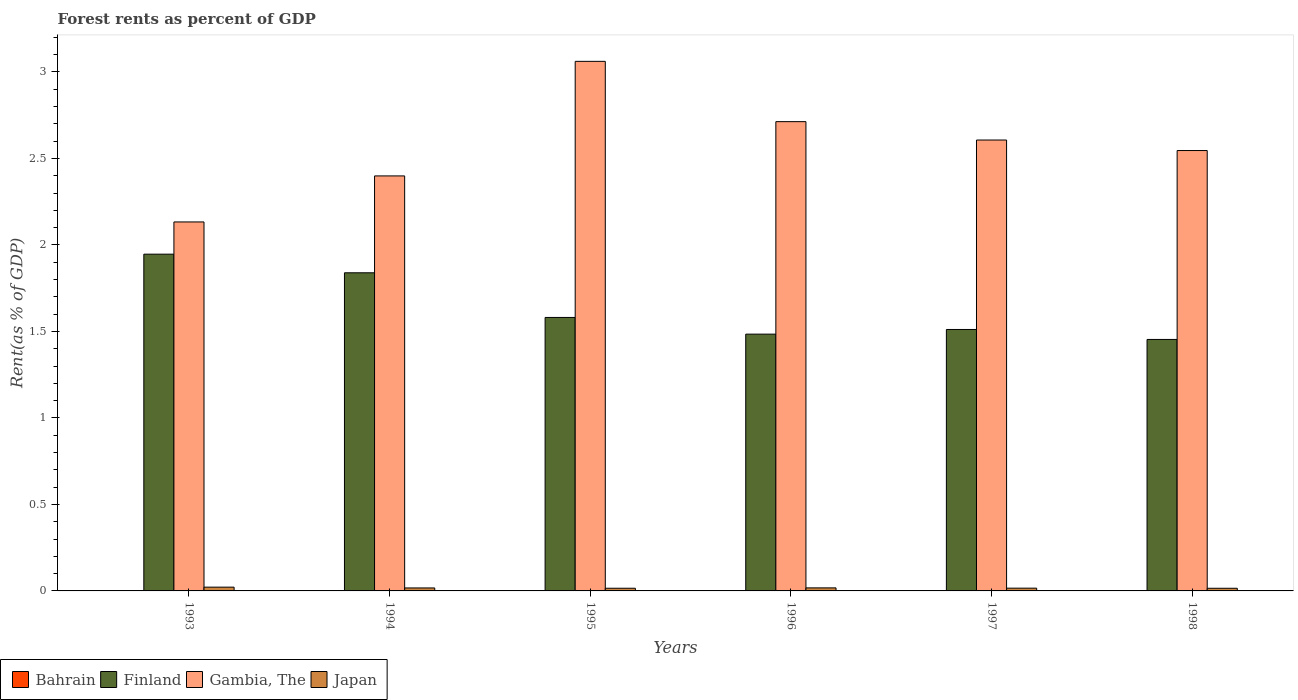How many different coloured bars are there?
Your answer should be very brief. 4. How many groups of bars are there?
Offer a terse response. 6. Are the number of bars per tick equal to the number of legend labels?
Your answer should be very brief. Yes. How many bars are there on the 1st tick from the left?
Your answer should be very brief. 4. How many bars are there on the 6th tick from the right?
Make the answer very short. 4. What is the forest rent in Finland in 1993?
Keep it short and to the point. 1.95. Across all years, what is the maximum forest rent in Finland?
Your answer should be compact. 1.95. Across all years, what is the minimum forest rent in Gambia, The?
Your answer should be very brief. 2.13. In which year was the forest rent in Finland minimum?
Offer a terse response. 1998. What is the total forest rent in Japan in the graph?
Give a very brief answer. 0.1. What is the difference between the forest rent in Japan in 1995 and that in 1996?
Your answer should be compact. -0. What is the difference between the forest rent in Gambia, The in 1993 and the forest rent in Japan in 1997?
Provide a short and direct response. 2.12. What is the average forest rent in Japan per year?
Your response must be concise. 0.02. In the year 1996, what is the difference between the forest rent in Gambia, The and forest rent in Japan?
Ensure brevity in your answer.  2.7. What is the ratio of the forest rent in Finland in 1993 to that in 1995?
Ensure brevity in your answer.  1.23. Is the difference between the forest rent in Gambia, The in 1996 and 1998 greater than the difference between the forest rent in Japan in 1996 and 1998?
Provide a short and direct response. Yes. What is the difference between the highest and the second highest forest rent in Finland?
Provide a succinct answer. 0.11. What is the difference between the highest and the lowest forest rent in Japan?
Ensure brevity in your answer.  0.01. Is it the case that in every year, the sum of the forest rent in Bahrain and forest rent in Finland is greater than the sum of forest rent in Japan and forest rent in Gambia, The?
Make the answer very short. Yes. What does the 3rd bar from the right in 1997 represents?
Your answer should be very brief. Finland. Is it the case that in every year, the sum of the forest rent in Finland and forest rent in Bahrain is greater than the forest rent in Japan?
Provide a succinct answer. Yes. How many bars are there?
Your answer should be very brief. 24. What is the difference between two consecutive major ticks on the Y-axis?
Offer a terse response. 0.5. Are the values on the major ticks of Y-axis written in scientific E-notation?
Your response must be concise. No. Does the graph contain any zero values?
Your answer should be very brief. No. Does the graph contain grids?
Your answer should be compact. No. How many legend labels are there?
Ensure brevity in your answer.  4. How are the legend labels stacked?
Give a very brief answer. Horizontal. What is the title of the graph?
Provide a short and direct response. Forest rents as percent of GDP. Does "Middle income" appear as one of the legend labels in the graph?
Ensure brevity in your answer.  No. What is the label or title of the X-axis?
Your answer should be compact. Years. What is the label or title of the Y-axis?
Keep it short and to the point. Rent(as % of GDP). What is the Rent(as % of GDP) of Bahrain in 1993?
Make the answer very short. 0. What is the Rent(as % of GDP) of Finland in 1993?
Make the answer very short. 1.95. What is the Rent(as % of GDP) of Gambia, The in 1993?
Provide a short and direct response. 2.13. What is the Rent(as % of GDP) in Japan in 1993?
Provide a succinct answer. 0.02. What is the Rent(as % of GDP) of Bahrain in 1994?
Provide a succinct answer. 0. What is the Rent(as % of GDP) of Finland in 1994?
Your response must be concise. 1.84. What is the Rent(as % of GDP) of Gambia, The in 1994?
Make the answer very short. 2.4. What is the Rent(as % of GDP) of Japan in 1994?
Your answer should be very brief. 0.02. What is the Rent(as % of GDP) in Bahrain in 1995?
Provide a short and direct response. 0. What is the Rent(as % of GDP) of Finland in 1995?
Make the answer very short. 1.58. What is the Rent(as % of GDP) of Gambia, The in 1995?
Provide a succinct answer. 3.06. What is the Rent(as % of GDP) in Japan in 1995?
Your answer should be very brief. 0.02. What is the Rent(as % of GDP) of Bahrain in 1996?
Make the answer very short. 0. What is the Rent(as % of GDP) in Finland in 1996?
Your response must be concise. 1.48. What is the Rent(as % of GDP) of Gambia, The in 1996?
Your response must be concise. 2.71. What is the Rent(as % of GDP) of Japan in 1996?
Provide a short and direct response. 0.02. What is the Rent(as % of GDP) in Bahrain in 1997?
Your response must be concise. 0. What is the Rent(as % of GDP) in Finland in 1997?
Ensure brevity in your answer.  1.51. What is the Rent(as % of GDP) of Gambia, The in 1997?
Give a very brief answer. 2.61. What is the Rent(as % of GDP) of Japan in 1997?
Offer a terse response. 0.02. What is the Rent(as % of GDP) in Bahrain in 1998?
Ensure brevity in your answer.  0. What is the Rent(as % of GDP) of Finland in 1998?
Keep it short and to the point. 1.45. What is the Rent(as % of GDP) in Gambia, The in 1998?
Your response must be concise. 2.55. What is the Rent(as % of GDP) in Japan in 1998?
Offer a terse response. 0.02. Across all years, what is the maximum Rent(as % of GDP) of Bahrain?
Provide a short and direct response. 0. Across all years, what is the maximum Rent(as % of GDP) in Finland?
Provide a short and direct response. 1.95. Across all years, what is the maximum Rent(as % of GDP) in Gambia, The?
Ensure brevity in your answer.  3.06. Across all years, what is the maximum Rent(as % of GDP) in Japan?
Offer a terse response. 0.02. Across all years, what is the minimum Rent(as % of GDP) of Bahrain?
Offer a terse response. 0. Across all years, what is the minimum Rent(as % of GDP) of Finland?
Keep it short and to the point. 1.45. Across all years, what is the minimum Rent(as % of GDP) in Gambia, The?
Ensure brevity in your answer.  2.13. Across all years, what is the minimum Rent(as % of GDP) of Japan?
Your answer should be compact. 0.02. What is the total Rent(as % of GDP) of Bahrain in the graph?
Provide a short and direct response. 0.01. What is the total Rent(as % of GDP) of Finland in the graph?
Your response must be concise. 9.82. What is the total Rent(as % of GDP) of Gambia, The in the graph?
Give a very brief answer. 15.46. What is the total Rent(as % of GDP) in Japan in the graph?
Provide a succinct answer. 0.1. What is the difference between the Rent(as % of GDP) in Finland in 1993 and that in 1994?
Ensure brevity in your answer.  0.11. What is the difference between the Rent(as % of GDP) of Gambia, The in 1993 and that in 1994?
Ensure brevity in your answer.  -0.27. What is the difference between the Rent(as % of GDP) in Japan in 1993 and that in 1994?
Provide a succinct answer. 0. What is the difference between the Rent(as % of GDP) of Finland in 1993 and that in 1995?
Provide a succinct answer. 0.37. What is the difference between the Rent(as % of GDP) in Gambia, The in 1993 and that in 1995?
Provide a short and direct response. -0.93. What is the difference between the Rent(as % of GDP) in Japan in 1993 and that in 1995?
Make the answer very short. 0.01. What is the difference between the Rent(as % of GDP) in Bahrain in 1993 and that in 1996?
Your answer should be compact. 0. What is the difference between the Rent(as % of GDP) in Finland in 1993 and that in 1996?
Give a very brief answer. 0.46. What is the difference between the Rent(as % of GDP) of Gambia, The in 1993 and that in 1996?
Make the answer very short. -0.58. What is the difference between the Rent(as % of GDP) of Japan in 1993 and that in 1996?
Your answer should be very brief. 0. What is the difference between the Rent(as % of GDP) of Bahrain in 1993 and that in 1997?
Ensure brevity in your answer.  -0. What is the difference between the Rent(as % of GDP) of Finland in 1993 and that in 1997?
Offer a very short reply. 0.44. What is the difference between the Rent(as % of GDP) of Gambia, The in 1993 and that in 1997?
Make the answer very short. -0.47. What is the difference between the Rent(as % of GDP) in Japan in 1993 and that in 1997?
Make the answer very short. 0.01. What is the difference between the Rent(as % of GDP) of Bahrain in 1993 and that in 1998?
Ensure brevity in your answer.  -0. What is the difference between the Rent(as % of GDP) in Finland in 1993 and that in 1998?
Give a very brief answer. 0.49. What is the difference between the Rent(as % of GDP) of Gambia, The in 1993 and that in 1998?
Give a very brief answer. -0.41. What is the difference between the Rent(as % of GDP) in Japan in 1993 and that in 1998?
Ensure brevity in your answer.  0.01. What is the difference between the Rent(as % of GDP) in Bahrain in 1994 and that in 1995?
Give a very brief answer. -0. What is the difference between the Rent(as % of GDP) in Finland in 1994 and that in 1995?
Give a very brief answer. 0.26. What is the difference between the Rent(as % of GDP) of Gambia, The in 1994 and that in 1995?
Your response must be concise. -0.66. What is the difference between the Rent(as % of GDP) in Japan in 1994 and that in 1995?
Give a very brief answer. 0. What is the difference between the Rent(as % of GDP) of Bahrain in 1994 and that in 1996?
Offer a very short reply. -0. What is the difference between the Rent(as % of GDP) of Finland in 1994 and that in 1996?
Your response must be concise. 0.35. What is the difference between the Rent(as % of GDP) in Gambia, The in 1994 and that in 1996?
Make the answer very short. -0.31. What is the difference between the Rent(as % of GDP) of Japan in 1994 and that in 1996?
Make the answer very short. -0. What is the difference between the Rent(as % of GDP) in Bahrain in 1994 and that in 1997?
Ensure brevity in your answer.  -0. What is the difference between the Rent(as % of GDP) in Finland in 1994 and that in 1997?
Your response must be concise. 0.33. What is the difference between the Rent(as % of GDP) in Gambia, The in 1994 and that in 1997?
Ensure brevity in your answer.  -0.21. What is the difference between the Rent(as % of GDP) in Japan in 1994 and that in 1997?
Offer a very short reply. 0. What is the difference between the Rent(as % of GDP) of Bahrain in 1994 and that in 1998?
Ensure brevity in your answer.  -0. What is the difference between the Rent(as % of GDP) of Finland in 1994 and that in 1998?
Offer a very short reply. 0.39. What is the difference between the Rent(as % of GDP) in Gambia, The in 1994 and that in 1998?
Your response must be concise. -0.15. What is the difference between the Rent(as % of GDP) of Japan in 1994 and that in 1998?
Make the answer very short. 0. What is the difference between the Rent(as % of GDP) in Bahrain in 1995 and that in 1996?
Your response must be concise. -0. What is the difference between the Rent(as % of GDP) in Finland in 1995 and that in 1996?
Your response must be concise. 0.1. What is the difference between the Rent(as % of GDP) of Gambia, The in 1995 and that in 1996?
Offer a terse response. 0.35. What is the difference between the Rent(as % of GDP) of Japan in 1995 and that in 1996?
Offer a terse response. -0. What is the difference between the Rent(as % of GDP) of Bahrain in 1995 and that in 1997?
Your answer should be compact. -0. What is the difference between the Rent(as % of GDP) of Finland in 1995 and that in 1997?
Provide a succinct answer. 0.07. What is the difference between the Rent(as % of GDP) in Gambia, The in 1995 and that in 1997?
Offer a terse response. 0.45. What is the difference between the Rent(as % of GDP) of Japan in 1995 and that in 1997?
Offer a very short reply. -0. What is the difference between the Rent(as % of GDP) of Bahrain in 1995 and that in 1998?
Provide a short and direct response. -0. What is the difference between the Rent(as % of GDP) in Finland in 1995 and that in 1998?
Offer a very short reply. 0.13. What is the difference between the Rent(as % of GDP) of Gambia, The in 1995 and that in 1998?
Make the answer very short. 0.52. What is the difference between the Rent(as % of GDP) in Bahrain in 1996 and that in 1997?
Offer a terse response. -0. What is the difference between the Rent(as % of GDP) in Finland in 1996 and that in 1997?
Keep it short and to the point. -0.03. What is the difference between the Rent(as % of GDP) of Gambia, The in 1996 and that in 1997?
Give a very brief answer. 0.11. What is the difference between the Rent(as % of GDP) of Japan in 1996 and that in 1997?
Offer a terse response. 0. What is the difference between the Rent(as % of GDP) of Bahrain in 1996 and that in 1998?
Offer a terse response. -0. What is the difference between the Rent(as % of GDP) of Finland in 1996 and that in 1998?
Your response must be concise. 0.03. What is the difference between the Rent(as % of GDP) in Gambia, The in 1996 and that in 1998?
Ensure brevity in your answer.  0.17. What is the difference between the Rent(as % of GDP) of Japan in 1996 and that in 1998?
Provide a short and direct response. 0. What is the difference between the Rent(as % of GDP) of Bahrain in 1997 and that in 1998?
Your answer should be very brief. -0. What is the difference between the Rent(as % of GDP) in Finland in 1997 and that in 1998?
Ensure brevity in your answer.  0.06. What is the difference between the Rent(as % of GDP) in Gambia, The in 1997 and that in 1998?
Offer a terse response. 0.06. What is the difference between the Rent(as % of GDP) of Japan in 1997 and that in 1998?
Offer a very short reply. 0. What is the difference between the Rent(as % of GDP) of Bahrain in 1993 and the Rent(as % of GDP) of Finland in 1994?
Provide a succinct answer. -1.84. What is the difference between the Rent(as % of GDP) in Bahrain in 1993 and the Rent(as % of GDP) in Gambia, The in 1994?
Provide a succinct answer. -2.4. What is the difference between the Rent(as % of GDP) of Bahrain in 1993 and the Rent(as % of GDP) of Japan in 1994?
Offer a very short reply. -0.02. What is the difference between the Rent(as % of GDP) in Finland in 1993 and the Rent(as % of GDP) in Gambia, The in 1994?
Ensure brevity in your answer.  -0.45. What is the difference between the Rent(as % of GDP) in Finland in 1993 and the Rent(as % of GDP) in Japan in 1994?
Keep it short and to the point. 1.93. What is the difference between the Rent(as % of GDP) in Gambia, The in 1993 and the Rent(as % of GDP) in Japan in 1994?
Your answer should be compact. 2.12. What is the difference between the Rent(as % of GDP) of Bahrain in 1993 and the Rent(as % of GDP) of Finland in 1995?
Offer a terse response. -1.58. What is the difference between the Rent(as % of GDP) of Bahrain in 1993 and the Rent(as % of GDP) of Gambia, The in 1995?
Keep it short and to the point. -3.06. What is the difference between the Rent(as % of GDP) in Bahrain in 1993 and the Rent(as % of GDP) in Japan in 1995?
Offer a terse response. -0.01. What is the difference between the Rent(as % of GDP) in Finland in 1993 and the Rent(as % of GDP) in Gambia, The in 1995?
Provide a short and direct response. -1.11. What is the difference between the Rent(as % of GDP) of Finland in 1993 and the Rent(as % of GDP) of Japan in 1995?
Offer a very short reply. 1.93. What is the difference between the Rent(as % of GDP) in Gambia, The in 1993 and the Rent(as % of GDP) in Japan in 1995?
Your answer should be compact. 2.12. What is the difference between the Rent(as % of GDP) in Bahrain in 1993 and the Rent(as % of GDP) in Finland in 1996?
Provide a short and direct response. -1.48. What is the difference between the Rent(as % of GDP) in Bahrain in 1993 and the Rent(as % of GDP) in Gambia, The in 1996?
Offer a very short reply. -2.71. What is the difference between the Rent(as % of GDP) of Bahrain in 1993 and the Rent(as % of GDP) of Japan in 1996?
Your response must be concise. -0.02. What is the difference between the Rent(as % of GDP) of Finland in 1993 and the Rent(as % of GDP) of Gambia, The in 1996?
Provide a succinct answer. -0.77. What is the difference between the Rent(as % of GDP) in Finland in 1993 and the Rent(as % of GDP) in Japan in 1996?
Make the answer very short. 1.93. What is the difference between the Rent(as % of GDP) in Gambia, The in 1993 and the Rent(as % of GDP) in Japan in 1996?
Your answer should be compact. 2.12. What is the difference between the Rent(as % of GDP) of Bahrain in 1993 and the Rent(as % of GDP) of Finland in 1997?
Ensure brevity in your answer.  -1.51. What is the difference between the Rent(as % of GDP) in Bahrain in 1993 and the Rent(as % of GDP) in Gambia, The in 1997?
Give a very brief answer. -2.6. What is the difference between the Rent(as % of GDP) of Bahrain in 1993 and the Rent(as % of GDP) of Japan in 1997?
Your response must be concise. -0.01. What is the difference between the Rent(as % of GDP) of Finland in 1993 and the Rent(as % of GDP) of Gambia, The in 1997?
Keep it short and to the point. -0.66. What is the difference between the Rent(as % of GDP) in Finland in 1993 and the Rent(as % of GDP) in Japan in 1997?
Make the answer very short. 1.93. What is the difference between the Rent(as % of GDP) in Gambia, The in 1993 and the Rent(as % of GDP) in Japan in 1997?
Make the answer very short. 2.12. What is the difference between the Rent(as % of GDP) in Bahrain in 1993 and the Rent(as % of GDP) in Finland in 1998?
Provide a short and direct response. -1.45. What is the difference between the Rent(as % of GDP) of Bahrain in 1993 and the Rent(as % of GDP) of Gambia, The in 1998?
Offer a very short reply. -2.54. What is the difference between the Rent(as % of GDP) of Bahrain in 1993 and the Rent(as % of GDP) of Japan in 1998?
Your answer should be compact. -0.01. What is the difference between the Rent(as % of GDP) of Finland in 1993 and the Rent(as % of GDP) of Gambia, The in 1998?
Make the answer very short. -0.6. What is the difference between the Rent(as % of GDP) of Finland in 1993 and the Rent(as % of GDP) of Japan in 1998?
Ensure brevity in your answer.  1.93. What is the difference between the Rent(as % of GDP) of Gambia, The in 1993 and the Rent(as % of GDP) of Japan in 1998?
Offer a terse response. 2.12. What is the difference between the Rent(as % of GDP) in Bahrain in 1994 and the Rent(as % of GDP) in Finland in 1995?
Offer a terse response. -1.58. What is the difference between the Rent(as % of GDP) in Bahrain in 1994 and the Rent(as % of GDP) in Gambia, The in 1995?
Make the answer very short. -3.06. What is the difference between the Rent(as % of GDP) of Bahrain in 1994 and the Rent(as % of GDP) of Japan in 1995?
Your answer should be compact. -0.01. What is the difference between the Rent(as % of GDP) in Finland in 1994 and the Rent(as % of GDP) in Gambia, The in 1995?
Give a very brief answer. -1.22. What is the difference between the Rent(as % of GDP) in Finland in 1994 and the Rent(as % of GDP) in Japan in 1995?
Give a very brief answer. 1.82. What is the difference between the Rent(as % of GDP) of Gambia, The in 1994 and the Rent(as % of GDP) of Japan in 1995?
Your answer should be very brief. 2.38. What is the difference between the Rent(as % of GDP) of Bahrain in 1994 and the Rent(as % of GDP) of Finland in 1996?
Give a very brief answer. -1.48. What is the difference between the Rent(as % of GDP) in Bahrain in 1994 and the Rent(as % of GDP) in Gambia, The in 1996?
Offer a terse response. -2.71. What is the difference between the Rent(as % of GDP) in Bahrain in 1994 and the Rent(as % of GDP) in Japan in 1996?
Offer a very short reply. -0.02. What is the difference between the Rent(as % of GDP) in Finland in 1994 and the Rent(as % of GDP) in Gambia, The in 1996?
Your response must be concise. -0.87. What is the difference between the Rent(as % of GDP) in Finland in 1994 and the Rent(as % of GDP) in Japan in 1996?
Offer a terse response. 1.82. What is the difference between the Rent(as % of GDP) in Gambia, The in 1994 and the Rent(as % of GDP) in Japan in 1996?
Ensure brevity in your answer.  2.38. What is the difference between the Rent(as % of GDP) in Bahrain in 1994 and the Rent(as % of GDP) in Finland in 1997?
Your answer should be compact. -1.51. What is the difference between the Rent(as % of GDP) in Bahrain in 1994 and the Rent(as % of GDP) in Gambia, The in 1997?
Your response must be concise. -2.61. What is the difference between the Rent(as % of GDP) in Bahrain in 1994 and the Rent(as % of GDP) in Japan in 1997?
Make the answer very short. -0.01. What is the difference between the Rent(as % of GDP) of Finland in 1994 and the Rent(as % of GDP) of Gambia, The in 1997?
Your answer should be compact. -0.77. What is the difference between the Rent(as % of GDP) in Finland in 1994 and the Rent(as % of GDP) in Japan in 1997?
Provide a succinct answer. 1.82. What is the difference between the Rent(as % of GDP) of Gambia, The in 1994 and the Rent(as % of GDP) of Japan in 1997?
Your answer should be very brief. 2.38. What is the difference between the Rent(as % of GDP) in Bahrain in 1994 and the Rent(as % of GDP) in Finland in 1998?
Keep it short and to the point. -1.45. What is the difference between the Rent(as % of GDP) in Bahrain in 1994 and the Rent(as % of GDP) in Gambia, The in 1998?
Your answer should be very brief. -2.54. What is the difference between the Rent(as % of GDP) of Bahrain in 1994 and the Rent(as % of GDP) of Japan in 1998?
Give a very brief answer. -0.01. What is the difference between the Rent(as % of GDP) in Finland in 1994 and the Rent(as % of GDP) in Gambia, The in 1998?
Provide a short and direct response. -0.71. What is the difference between the Rent(as % of GDP) in Finland in 1994 and the Rent(as % of GDP) in Japan in 1998?
Your answer should be compact. 1.82. What is the difference between the Rent(as % of GDP) of Gambia, The in 1994 and the Rent(as % of GDP) of Japan in 1998?
Your answer should be compact. 2.38. What is the difference between the Rent(as % of GDP) in Bahrain in 1995 and the Rent(as % of GDP) in Finland in 1996?
Provide a succinct answer. -1.48. What is the difference between the Rent(as % of GDP) in Bahrain in 1995 and the Rent(as % of GDP) in Gambia, The in 1996?
Provide a succinct answer. -2.71. What is the difference between the Rent(as % of GDP) of Bahrain in 1995 and the Rent(as % of GDP) of Japan in 1996?
Ensure brevity in your answer.  -0.02. What is the difference between the Rent(as % of GDP) of Finland in 1995 and the Rent(as % of GDP) of Gambia, The in 1996?
Give a very brief answer. -1.13. What is the difference between the Rent(as % of GDP) in Finland in 1995 and the Rent(as % of GDP) in Japan in 1996?
Keep it short and to the point. 1.56. What is the difference between the Rent(as % of GDP) of Gambia, The in 1995 and the Rent(as % of GDP) of Japan in 1996?
Offer a very short reply. 3.04. What is the difference between the Rent(as % of GDP) in Bahrain in 1995 and the Rent(as % of GDP) in Finland in 1997?
Provide a succinct answer. -1.51. What is the difference between the Rent(as % of GDP) of Bahrain in 1995 and the Rent(as % of GDP) of Gambia, The in 1997?
Give a very brief answer. -2.6. What is the difference between the Rent(as % of GDP) in Bahrain in 1995 and the Rent(as % of GDP) in Japan in 1997?
Offer a very short reply. -0.01. What is the difference between the Rent(as % of GDP) in Finland in 1995 and the Rent(as % of GDP) in Gambia, The in 1997?
Your response must be concise. -1.03. What is the difference between the Rent(as % of GDP) in Finland in 1995 and the Rent(as % of GDP) in Japan in 1997?
Provide a short and direct response. 1.56. What is the difference between the Rent(as % of GDP) in Gambia, The in 1995 and the Rent(as % of GDP) in Japan in 1997?
Keep it short and to the point. 3.05. What is the difference between the Rent(as % of GDP) of Bahrain in 1995 and the Rent(as % of GDP) of Finland in 1998?
Offer a terse response. -1.45. What is the difference between the Rent(as % of GDP) of Bahrain in 1995 and the Rent(as % of GDP) of Gambia, The in 1998?
Ensure brevity in your answer.  -2.54. What is the difference between the Rent(as % of GDP) in Bahrain in 1995 and the Rent(as % of GDP) in Japan in 1998?
Keep it short and to the point. -0.01. What is the difference between the Rent(as % of GDP) of Finland in 1995 and the Rent(as % of GDP) of Gambia, The in 1998?
Ensure brevity in your answer.  -0.96. What is the difference between the Rent(as % of GDP) of Finland in 1995 and the Rent(as % of GDP) of Japan in 1998?
Your answer should be very brief. 1.57. What is the difference between the Rent(as % of GDP) of Gambia, The in 1995 and the Rent(as % of GDP) of Japan in 1998?
Your response must be concise. 3.05. What is the difference between the Rent(as % of GDP) of Bahrain in 1996 and the Rent(as % of GDP) of Finland in 1997?
Keep it short and to the point. -1.51. What is the difference between the Rent(as % of GDP) of Bahrain in 1996 and the Rent(as % of GDP) of Gambia, The in 1997?
Provide a succinct answer. -2.6. What is the difference between the Rent(as % of GDP) in Bahrain in 1996 and the Rent(as % of GDP) in Japan in 1997?
Make the answer very short. -0.01. What is the difference between the Rent(as % of GDP) in Finland in 1996 and the Rent(as % of GDP) in Gambia, The in 1997?
Provide a succinct answer. -1.12. What is the difference between the Rent(as % of GDP) of Finland in 1996 and the Rent(as % of GDP) of Japan in 1997?
Offer a very short reply. 1.47. What is the difference between the Rent(as % of GDP) in Gambia, The in 1996 and the Rent(as % of GDP) in Japan in 1997?
Give a very brief answer. 2.7. What is the difference between the Rent(as % of GDP) of Bahrain in 1996 and the Rent(as % of GDP) of Finland in 1998?
Make the answer very short. -1.45. What is the difference between the Rent(as % of GDP) of Bahrain in 1996 and the Rent(as % of GDP) of Gambia, The in 1998?
Provide a succinct answer. -2.54. What is the difference between the Rent(as % of GDP) of Bahrain in 1996 and the Rent(as % of GDP) of Japan in 1998?
Keep it short and to the point. -0.01. What is the difference between the Rent(as % of GDP) of Finland in 1996 and the Rent(as % of GDP) of Gambia, The in 1998?
Provide a succinct answer. -1.06. What is the difference between the Rent(as % of GDP) of Finland in 1996 and the Rent(as % of GDP) of Japan in 1998?
Your answer should be compact. 1.47. What is the difference between the Rent(as % of GDP) in Gambia, The in 1996 and the Rent(as % of GDP) in Japan in 1998?
Offer a terse response. 2.7. What is the difference between the Rent(as % of GDP) in Bahrain in 1997 and the Rent(as % of GDP) in Finland in 1998?
Your response must be concise. -1.45. What is the difference between the Rent(as % of GDP) of Bahrain in 1997 and the Rent(as % of GDP) of Gambia, The in 1998?
Give a very brief answer. -2.54. What is the difference between the Rent(as % of GDP) in Bahrain in 1997 and the Rent(as % of GDP) in Japan in 1998?
Offer a very short reply. -0.01. What is the difference between the Rent(as % of GDP) in Finland in 1997 and the Rent(as % of GDP) in Gambia, The in 1998?
Keep it short and to the point. -1.03. What is the difference between the Rent(as % of GDP) of Finland in 1997 and the Rent(as % of GDP) of Japan in 1998?
Provide a succinct answer. 1.5. What is the difference between the Rent(as % of GDP) of Gambia, The in 1997 and the Rent(as % of GDP) of Japan in 1998?
Make the answer very short. 2.59. What is the average Rent(as % of GDP) of Bahrain per year?
Provide a succinct answer. 0. What is the average Rent(as % of GDP) of Finland per year?
Your answer should be very brief. 1.64. What is the average Rent(as % of GDP) of Gambia, The per year?
Make the answer very short. 2.58. What is the average Rent(as % of GDP) of Japan per year?
Provide a short and direct response. 0.02. In the year 1993, what is the difference between the Rent(as % of GDP) in Bahrain and Rent(as % of GDP) in Finland?
Make the answer very short. -1.95. In the year 1993, what is the difference between the Rent(as % of GDP) in Bahrain and Rent(as % of GDP) in Gambia, The?
Provide a succinct answer. -2.13. In the year 1993, what is the difference between the Rent(as % of GDP) of Bahrain and Rent(as % of GDP) of Japan?
Make the answer very short. -0.02. In the year 1993, what is the difference between the Rent(as % of GDP) of Finland and Rent(as % of GDP) of Gambia, The?
Offer a very short reply. -0.19. In the year 1993, what is the difference between the Rent(as % of GDP) in Finland and Rent(as % of GDP) in Japan?
Give a very brief answer. 1.92. In the year 1993, what is the difference between the Rent(as % of GDP) in Gambia, The and Rent(as % of GDP) in Japan?
Offer a terse response. 2.11. In the year 1994, what is the difference between the Rent(as % of GDP) of Bahrain and Rent(as % of GDP) of Finland?
Your answer should be very brief. -1.84. In the year 1994, what is the difference between the Rent(as % of GDP) in Bahrain and Rent(as % of GDP) in Gambia, The?
Your answer should be very brief. -2.4. In the year 1994, what is the difference between the Rent(as % of GDP) in Bahrain and Rent(as % of GDP) in Japan?
Provide a short and direct response. -0.02. In the year 1994, what is the difference between the Rent(as % of GDP) in Finland and Rent(as % of GDP) in Gambia, The?
Give a very brief answer. -0.56. In the year 1994, what is the difference between the Rent(as % of GDP) of Finland and Rent(as % of GDP) of Japan?
Provide a succinct answer. 1.82. In the year 1994, what is the difference between the Rent(as % of GDP) in Gambia, The and Rent(as % of GDP) in Japan?
Ensure brevity in your answer.  2.38. In the year 1995, what is the difference between the Rent(as % of GDP) in Bahrain and Rent(as % of GDP) in Finland?
Keep it short and to the point. -1.58. In the year 1995, what is the difference between the Rent(as % of GDP) of Bahrain and Rent(as % of GDP) of Gambia, The?
Keep it short and to the point. -3.06. In the year 1995, what is the difference between the Rent(as % of GDP) in Bahrain and Rent(as % of GDP) in Japan?
Make the answer very short. -0.01. In the year 1995, what is the difference between the Rent(as % of GDP) of Finland and Rent(as % of GDP) of Gambia, The?
Give a very brief answer. -1.48. In the year 1995, what is the difference between the Rent(as % of GDP) in Finland and Rent(as % of GDP) in Japan?
Provide a short and direct response. 1.57. In the year 1995, what is the difference between the Rent(as % of GDP) in Gambia, The and Rent(as % of GDP) in Japan?
Ensure brevity in your answer.  3.05. In the year 1996, what is the difference between the Rent(as % of GDP) in Bahrain and Rent(as % of GDP) in Finland?
Offer a very short reply. -1.48. In the year 1996, what is the difference between the Rent(as % of GDP) in Bahrain and Rent(as % of GDP) in Gambia, The?
Your answer should be very brief. -2.71. In the year 1996, what is the difference between the Rent(as % of GDP) of Bahrain and Rent(as % of GDP) of Japan?
Offer a very short reply. -0.02. In the year 1996, what is the difference between the Rent(as % of GDP) of Finland and Rent(as % of GDP) of Gambia, The?
Provide a succinct answer. -1.23. In the year 1996, what is the difference between the Rent(as % of GDP) in Finland and Rent(as % of GDP) in Japan?
Your answer should be very brief. 1.47. In the year 1996, what is the difference between the Rent(as % of GDP) in Gambia, The and Rent(as % of GDP) in Japan?
Make the answer very short. 2.69. In the year 1997, what is the difference between the Rent(as % of GDP) in Bahrain and Rent(as % of GDP) in Finland?
Your answer should be compact. -1.51. In the year 1997, what is the difference between the Rent(as % of GDP) in Bahrain and Rent(as % of GDP) in Gambia, The?
Keep it short and to the point. -2.6. In the year 1997, what is the difference between the Rent(as % of GDP) of Bahrain and Rent(as % of GDP) of Japan?
Ensure brevity in your answer.  -0.01. In the year 1997, what is the difference between the Rent(as % of GDP) of Finland and Rent(as % of GDP) of Gambia, The?
Keep it short and to the point. -1.1. In the year 1997, what is the difference between the Rent(as % of GDP) of Finland and Rent(as % of GDP) of Japan?
Give a very brief answer. 1.5. In the year 1997, what is the difference between the Rent(as % of GDP) in Gambia, The and Rent(as % of GDP) in Japan?
Your response must be concise. 2.59. In the year 1998, what is the difference between the Rent(as % of GDP) of Bahrain and Rent(as % of GDP) of Finland?
Your answer should be very brief. -1.45. In the year 1998, what is the difference between the Rent(as % of GDP) of Bahrain and Rent(as % of GDP) of Gambia, The?
Offer a terse response. -2.54. In the year 1998, what is the difference between the Rent(as % of GDP) in Bahrain and Rent(as % of GDP) in Japan?
Make the answer very short. -0.01. In the year 1998, what is the difference between the Rent(as % of GDP) of Finland and Rent(as % of GDP) of Gambia, The?
Give a very brief answer. -1.09. In the year 1998, what is the difference between the Rent(as % of GDP) in Finland and Rent(as % of GDP) in Japan?
Your answer should be compact. 1.44. In the year 1998, what is the difference between the Rent(as % of GDP) in Gambia, The and Rent(as % of GDP) in Japan?
Give a very brief answer. 2.53. What is the ratio of the Rent(as % of GDP) of Bahrain in 1993 to that in 1994?
Offer a very short reply. 1.38. What is the ratio of the Rent(as % of GDP) in Finland in 1993 to that in 1994?
Ensure brevity in your answer.  1.06. What is the ratio of the Rent(as % of GDP) of Gambia, The in 1993 to that in 1994?
Ensure brevity in your answer.  0.89. What is the ratio of the Rent(as % of GDP) in Japan in 1993 to that in 1994?
Your answer should be compact. 1.27. What is the ratio of the Rent(as % of GDP) of Bahrain in 1993 to that in 1995?
Offer a very short reply. 1.15. What is the ratio of the Rent(as % of GDP) in Finland in 1993 to that in 1995?
Offer a very short reply. 1.23. What is the ratio of the Rent(as % of GDP) of Gambia, The in 1993 to that in 1995?
Provide a succinct answer. 0.7. What is the ratio of the Rent(as % of GDP) in Japan in 1993 to that in 1995?
Provide a succinct answer. 1.41. What is the ratio of the Rent(as % of GDP) in Bahrain in 1993 to that in 1996?
Provide a succinct answer. 1.02. What is the ratio of the Rent(as % of GDP) in Finland in 1993 to that in 1996?
Offer a very short reply. 1.31. What is the ratio of the Rent(as % of GDP) in Gambia, The in 1993 to that in 1996?
Offer a very short reply. 0.79. What is the ratio of the Rent(as % of GDP) in Japan in 1993 to that in 1996?
Provide a succinct answer. 1.24. What is the ratio of the Rent(as % of GDP) of Bahrain in 1993 to that in 1997?
Keep it short and to the point. 0.91. What is the ratio of the Rent(as % of GDP) of Finland in 1993 to that in 1997?
Give a very brief answer. 1.29. What is the ratio of the Rent(as % of GDP) in Gambia, The in 1993 to that in 1997?
Keep it short and to the point. 0.82. What is the ratio of the Rent(as % of GDP) in Japan in 1993 to that in 1997?
Keep it short and to the point. 1.37. What is the ratio of the Rent(as % of GDP) in Bahrain in 1993 to that in 1998?
Give a very brief answer. 0.85. What is the ratio of the Rent(as % of GDP) in Finland in 1993 to that in 1998?
Your answer should be very brief. 1.34. What is the ratio of the Rent(as % of GDP) of Gambia, The in 1993 to that in 1998?
Your response must be concise. 0.84. What is the ratio of the Rent(as % of GDP) of Japan in 1993 to that in 1998?
Provide a succinct answer. 1.43. What is the ratio of the Rent(as % of GDP) in Bahrain in 1994 to that in 1995?
Your answer should be compact. 0.84. What is the ratio of the Rent(as % of GDP) of Finland in 1994 to that in 1995?
Offer a terse response. 1.16. What is the ratio of the Rent(as % of GDP) of Gambia, The in 1994 to that in 1995?
Provide a short and direct response. 0.78. What is the ratio of the Rent(as % of GDP) in Japan in 1994 to that in 1995?
Provide a short and direct response. 1.11. What is the ratio of the Rent(as % of GDP) of Bahrain in 1994 to that in 1996?
Make the answer very short. 0.74. What is the ratio of the Rent(as % of GDP) of Finland in 1994 to that in 1996?
Offer a terse response. 1.24. What is the ratio of the Rent(as % of GDP) in Gambia, The in 1994 to that in 1996?
Give a very brief answer. 0.88. What is the ratio of the Rent(as % of GDP) in Japan in 1994 to that in 1996?
Ensure brevity in your answer.  0.98. What is the ratio of the Rent(as % of GDP) in Bahrain in 1994 to that in 1997?
Offer a terse response. 0.66. What is the ratio of the Rent(as % of GDP) of Finland in 1994 to that in 1997?
Offer a terse response. 1.22. What is the ratio of the Rent(as % of GDP) of Gambia, The in 1994 to that in 1997?
Offer a very short reply. 0.92. What is the ratio of the Rent(as % of GDP) of Japan in 1994 to that in 1997?
Give a very brief answer. 1.08. What is the ratio of the Rent(as % of GDP) in Bahrain in 1994 to that in 1998?
Offer a terse response. 0.62. What is the ratio of the Rent(as % of GDP) in Finland in 1994 to that in 1998?
Give a very brief answer. 1.27. What is the ratio of the Rent(as % of GDP) of Gambia, The in 1994 to that in 1998?
Your response must be concise. 0.94. What is the ratio of the Rent(as % of GDP) of Japan in 1994 to that in 1998?
Give a very brief answer. 1.12. What is the ratio of the Rent(as % of GDP) in Bahrain in 1995 to that in 1996?
Make the answer very short. 0.89. What is the ratio of the Rent(as % of GDP) in Finland in 1995 to that in 1996?
Your answer should be very brief. 1.06. What is the ratio of the Rent(as % of GDP) of Gambia, The in 1995 to that in 1996?
Provide a succinct answer. 1.13. What is the ratio of the Rent(as % of GDP) in Japan in 1995 to that in 1996?
Make the answer very short. 0.88. What is the ratio of the Rent(as % of GDP) of Bahrain in 1995 to that in 1997?
Offer a terse response. 0.79. What is the ratio of the Rent(as % of GDP) of Finland in 1995 to that in 1997?
Provide a succinct answer. 1.05. What is the ratio of the Rent(as % of GDP) in Gambia, The in 1995 to that in 1997?
Your answer should be very brief. 1.17. What is the ratio of the Rent(as % of GDP) of Japan in 1995 to that in 1997?
Keep it short and to the point. 0.97. What is the ratio of the Rent(as % of GDP) in Bahrain in 1995 to that in 1998?
Provide a short and direct response. 0.74. What is the ratio of the Rent(as % of GDP) of Finland in 1995 to that in 1998?
Give a very brief answer. 1.09. What is the ratio of the Rent(as % of GDP) of Gambia, The in 1995 to that in 1998?
Your answer should be compact. 1.2. What is the ratio of the Rent(as % of GDP) in Japan in 1995 to that in 1998?
Provide a succinct answer. 1.01. What is the ratio of the Rent(as % of GDP) in Bahrain in 1996 to that in 1997?
Make the answer very short. 0.89. What is the ratio of the Rent(as % of GDP) in Finland in 1996 to that in 1997?
Your response must be concise. 0.98. What is the ratio of the Rent(as % of GDP) in Gambia, The in 1996 to that in 1997?
Offer a very short reply. 1.04. What is the ratio of the Rent(as % of GDP) of Japan in 1996 to that in 1997?
Keep it short and to the point. 1.1. What is the ratio of the Rent(as % of GDP) in Bahrain in 1996 to that in 1998?
Make the answer very short. 0.84. What is the ratio of the Rent(as % of GDP) of Finland in 1996 to that in 1998?
Provide a short and direct response. 1.02. What is the ratio of the Rent(as % of GDP) in Gambia, The in 1996 to that in 1998?
Offer a very short reply. 1.07. What is the ratio of the Rent(as % of GDP) in Japan in 1996 to that in 1998?
Provide a succinct answer. 1.15. What is the ratio of the Rent(as % of GDP) in Bahrain in 1997 to that in 1998?
Offer a very short reply. 0.94. What is the ratio of the Rent(as % of GDP) in Finland in 1997 to that in 1998?
Your answer should be very brief. 1.04. What is the ratio of the Rent(as % of GDP) of Gambia, The in 1997 to that in 1998?
Provide a short and direct response. 1.02. What is the ratio of the Rent(as % of GDP) in Japan in 1997 to that in 1998?
Keep it short and to the point. 1.04. What is the difference between the highest and the second highest Rent(as % of GDP) in Finland?
Give a very brief answer. 0.11. What is the difference between the highest and the second highest Rent(as % of GDP) of Gambia, The?
Your answer should be very brief. 0.35. What is the difference between the highest and the second highest Rent(as % of GDP) in Japan?
Ensure brevity in your answer.  0. What is the difference between the highest and the lowest Rent(as % of GDP) of Bahrain?
Provide a short and direct response. 0. What is the difference between the highest and the lowest Rent(as % of GDP) in Finland?
Provide a short and direct response. 0.49. What is the difference between the highest and the lowest Rent(as % of GDP) of Gambia, The?
Ensure brevity in your answer.  0.93. What is the difference between the highest and the lowest Rent(as % of GDP) in Japan?
Your answer should be compact. 0.01. 